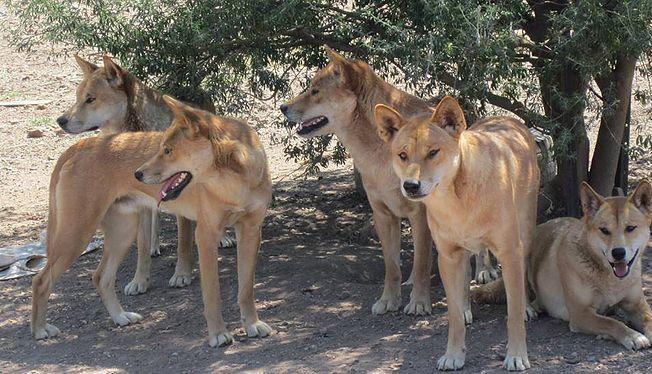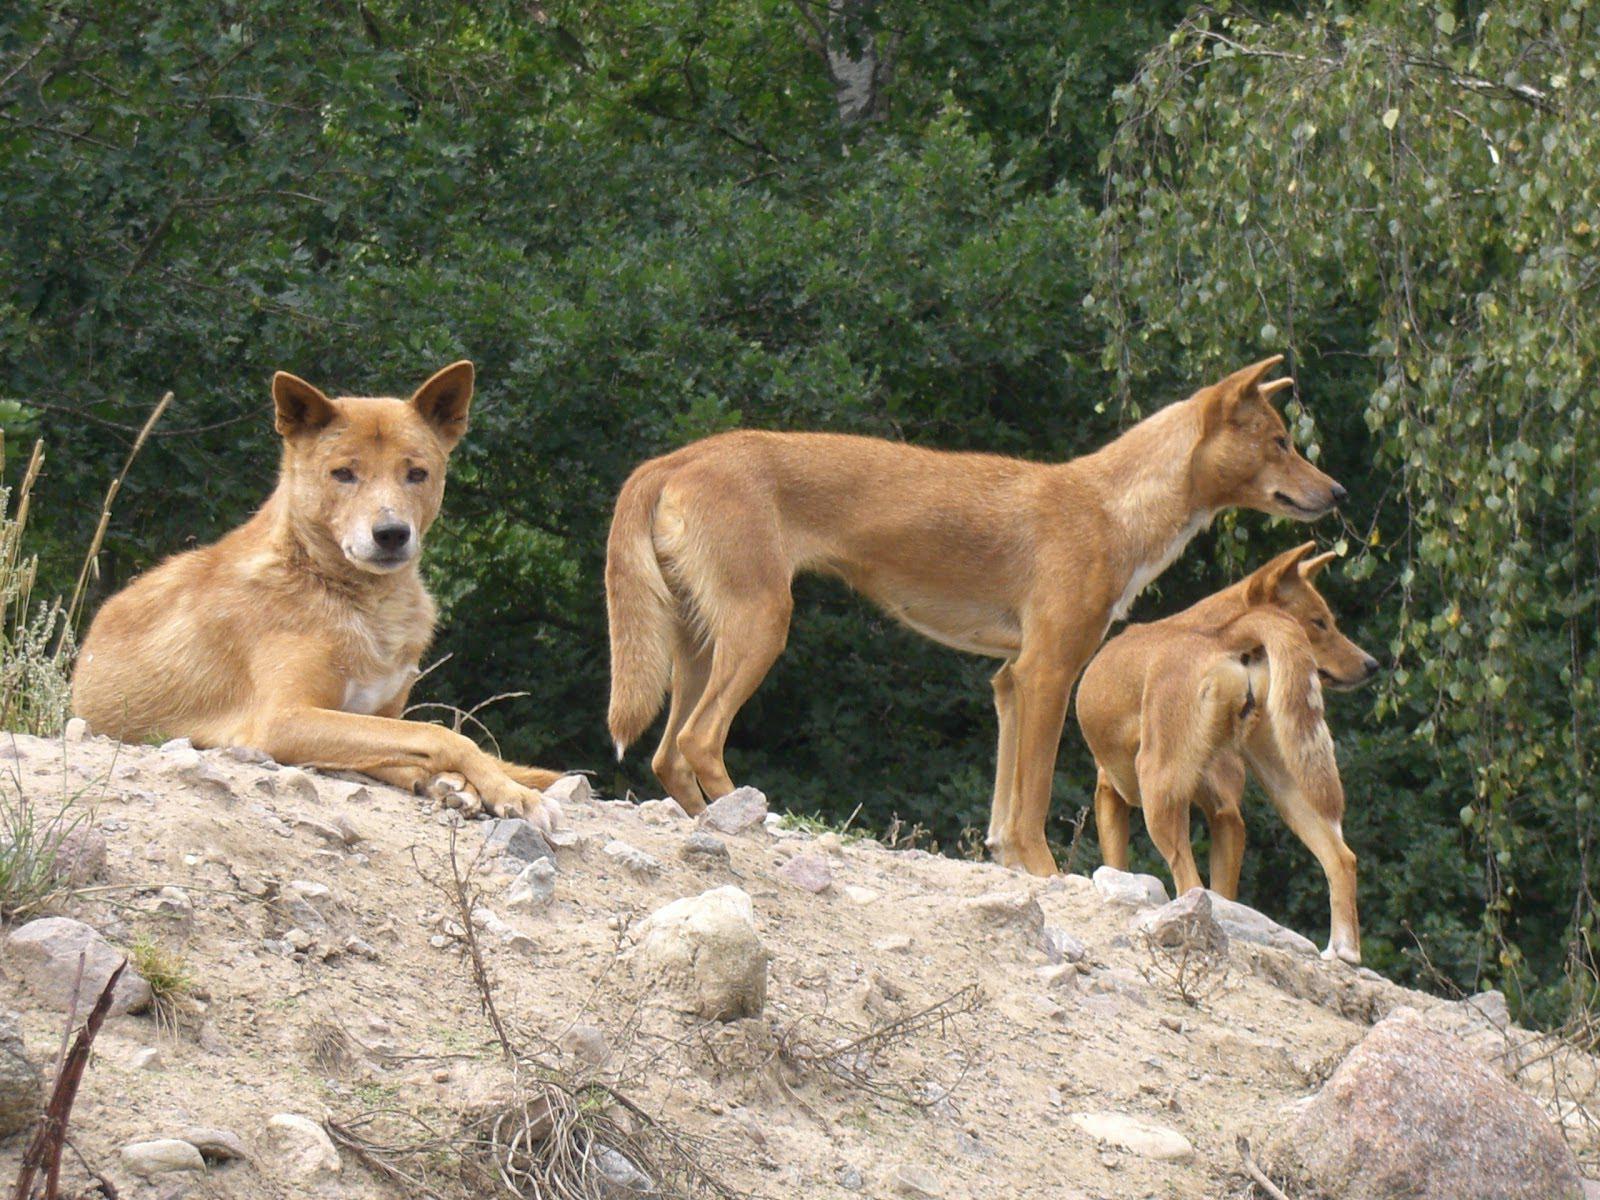The first image is the image on the left, the second image is the image on the right. Evaluate the accuracy of this statement regarding the images: "There ais at least one dog standing on a rocky hill". Is it true? Answer yes or no. Yes. The first image is the image on the left, the second image is the image on the right. Considering the images on both sides, is "There appear to be exactly eight dogs." valid? Answer yes or no. Yes. 